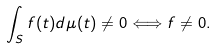<formula> <loc_0><loc_0><loc_500><loc_500>\int _ { S } f ( t ) d \mu ( t ) \neq 0 \Longleftrightarrow f \neq 0 .</formula> 